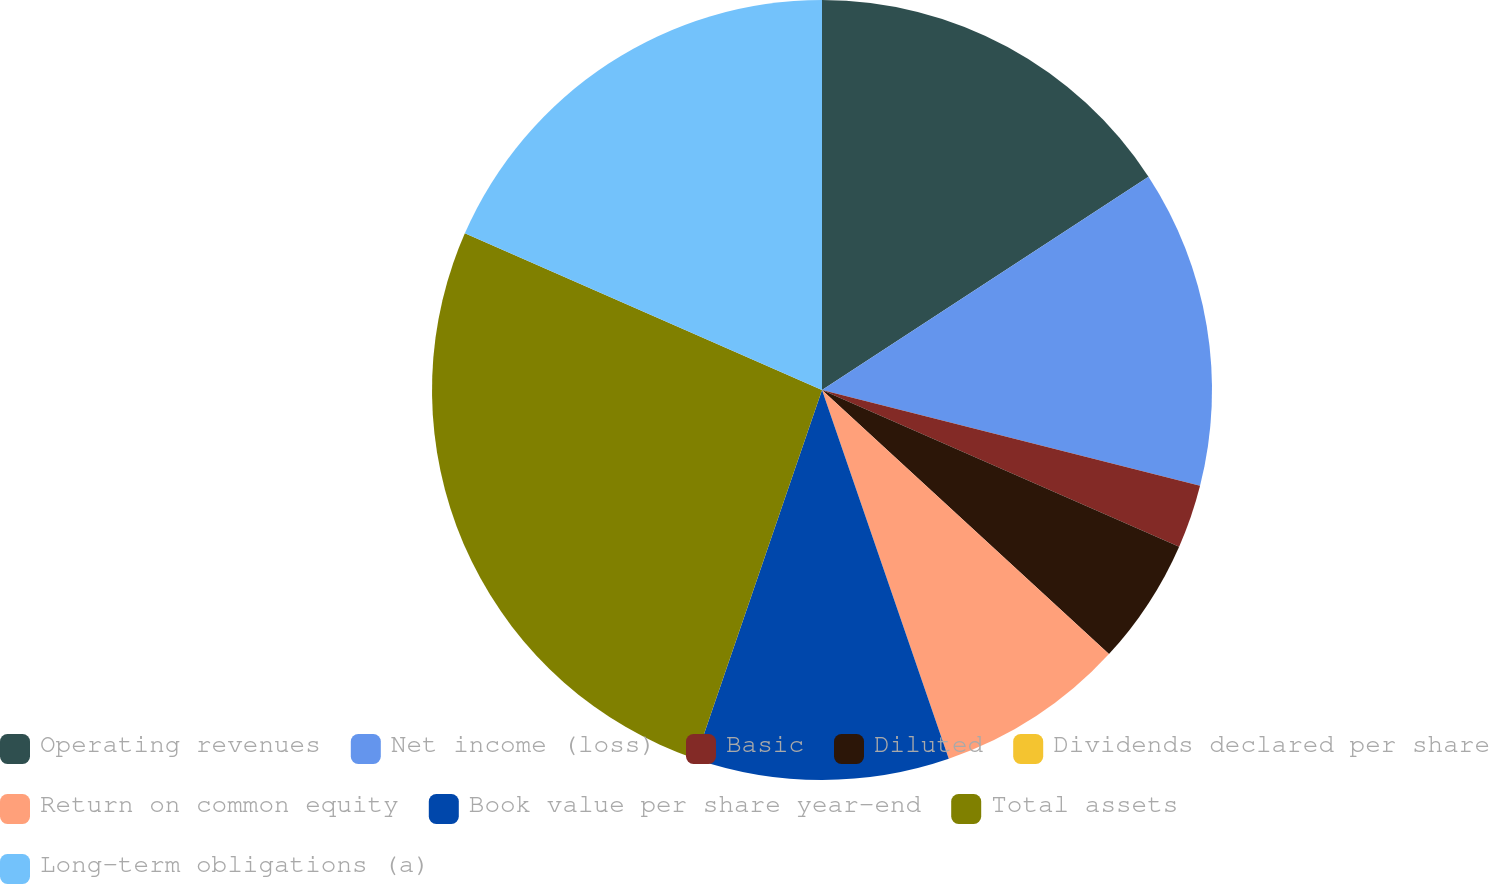Convert chart to OTSL. <chart><loc_0><loc_0><loc_500><loc_500><pie_chart><fcel>Operating revenues<fcel>Net income (loss)<fcel>Basic<fcel>Diluted<fcel>Dividends declared per share<fcel>Return on common equity<fcel>Book value per share year-end<fcel>Total assets<fcel>Long-term obligations (a)<nl><fcel>15.79%<fcel>13.16%<fcel>2.63%<fcel>5.26%<fcel>0.0%<fcel>7.89%<fcel>10.53%<fcel>26.32%<fcel>18.42%<nl></chart> 